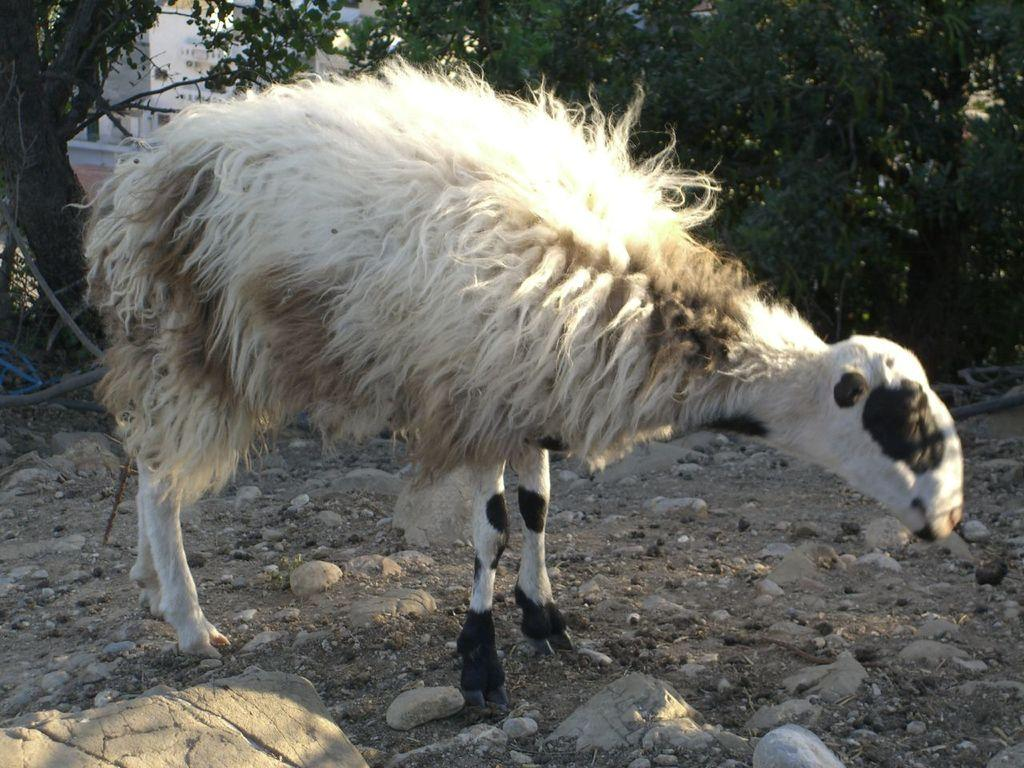What is the main subject in the foreground of the image? There is a sheep in the foreground of the image. Where is the sheep located? The sheep is on the land. What can be seen on the land besides the sheep? There are stones visible on the land. What is visible in the background of the image? There are trees and a building in the background of the image. How many dimes can be seen in the image? There are no dimes present in the image. What type of aftermath can be observed in the image? There is no aftermath depicted in the image; it shows a sheep on the land with stones, trees, and a building in the background. 